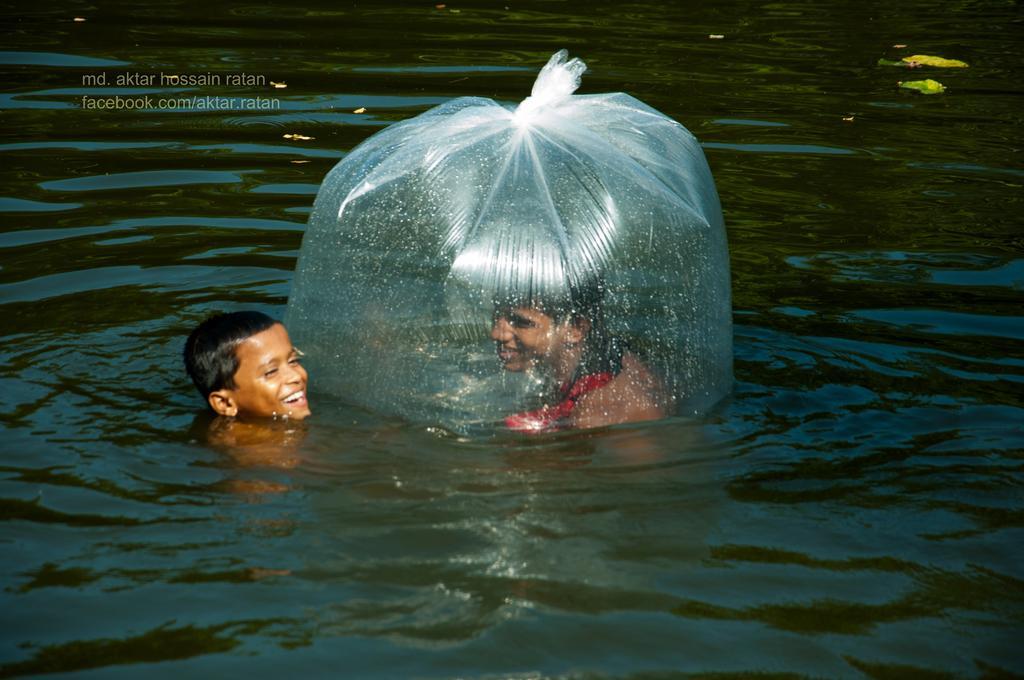Describe this image in one or two sentences. In this image we can see two persons in the water, among them, one person is inside the cover and at the top we can see some text. 